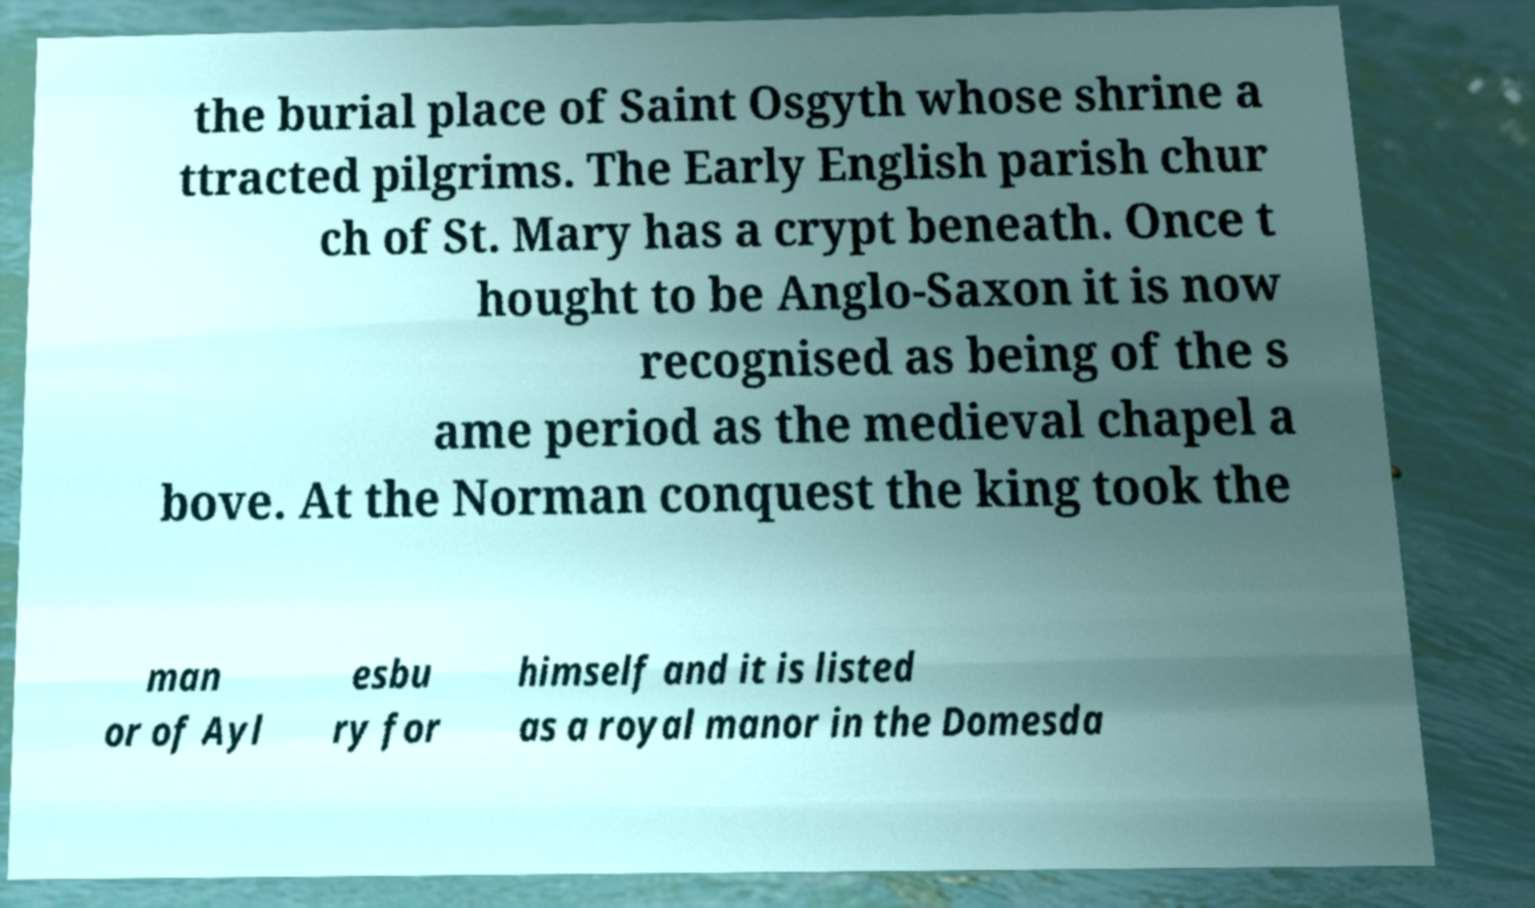Can you read and provide the text displayed in the image?This photo seems to have some interesting text. Can you extract and type it out for me? the burial place of Saint Osgyth whose shrine a ttracted pilgrims. The Early English parish chur ch of St. Mary has a crypt beneath. Once t hought to be Anglo-Saxon it is now recognised as being of the s ame period as the medieval chapel a bove. At the Norman conquest the king took the man or of Ayl esbu ry for himself and it is listed as a royal manor in the Domesda 